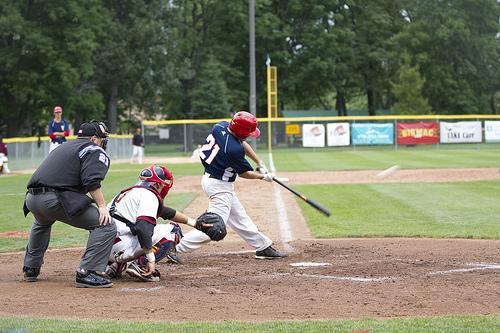How many people are at first base?
Give a very brief answer. 3. 